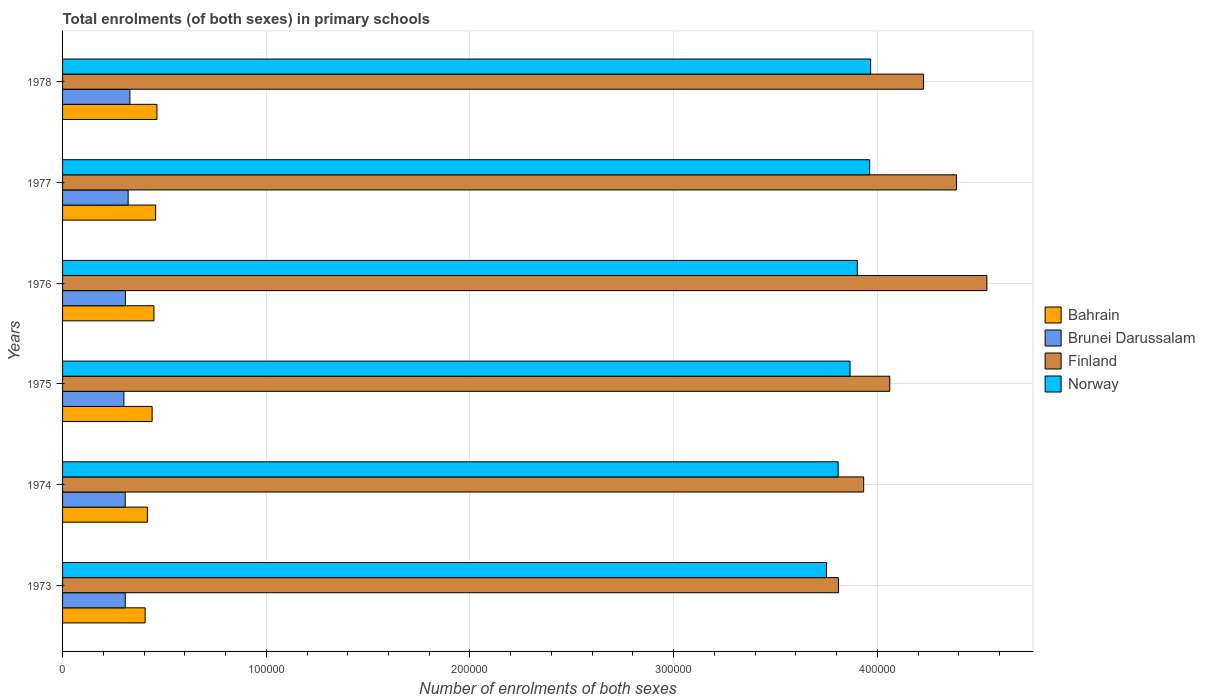How many groups of bars are there?
Your answer should be very brief. 6. What is the label of the 3rd group of bars from the top?
Provide a short and direct response. 1976. In how many cases, is the number of bars for a given year not equal to the number of legend labels?
Your response must be concise. 0. What is the number of enrolments in primary schools in Finland in 1978?
Provide a succinct answer. 4.23e+05. Across all years, what is the maximum number of enrolments in primary schools in Brunei Darussalam?
Offer a terse response. 3.31e+04. Across all years, what is the minimum number of enrolments in primary schools in Brunei Darussalam?
Your answer should be compact. 3.01e+04. In which year was the number of enrolments in primary schools in Bahrain maximum?
Keep it short and to the point. 1978. What is the total number of enrolments in primary schools in Bahrain in the graph?
Offer a very short reply. 2.63e+05. What is the difference between the number of enrolments in primary schools in Brunei Darussalam in 1973 and that in 1976?
Provide a succinct answer. -52. What is the difference between the number of enrolments in primary schools in Brunei Darussalam in 1978 and the number of enrolments in primary schools in Bahrain in 1975?
Provide a succinct answer. -1.09e+04. What is the average number of enrolments in primary schools in Norway per year?
Ensure brevity in your answer.  3.88e+05. In the year 1974, what is the difference between the number of enrolments in primary schools in Finland and number of enrolments in primary schools in Bahrain?
Offer a very short reply. 3.52e+05. What is the ratio of the number of enrolments in primary schools in Finland in 1974 to that in 1977?
Your response must be concise. 0.9. Is the difference between the number of enrolments in primary schools in Finland in 1973 and 1975 greater than the difference between the number of enrolments in primary schools in Bahrain in 1973 and 1975?
Provide a succinct answer. No. What is the difference between the highest and the second highest number of enrolments in primary schools in Norway?
Your answer should be very brief. 478. What is the difference between the highest and the lowest number of enrolments in primary schools in Norway?
Keep it short and to the point. 2.17e+04. In how many years, is the number of enrolments in primary schools in Brunei Darussalam greater than the average number of enrolments in primary schools in Brunei Darussalam taken over all years?
Provide a succinct answer. 2. Is it the case that in every year, the sum of the number of enrolments in primary schools in Norway and number of enrolments in primary schools in Bahrain is greater than the sum of number of enrolments in primary schools in Brunei Darussalam and number of enrolments in primary schools in Finland?
Make the answer very short. Yes. What does the 3rd bar from the top in 1975 represents?
Your answer should be compact. Brunei Darussalam. What does the 1st bar from the bottom in 1975 represents?
Give a very brief answer. Bahrain. Is it the case that in every year, the sum of the number of enrolments in primary schools in Bahrain and number of enrolments in primary schools in Brunei Darussalam is greater than the number of enrolments in primary schools in Norway?
Make the answer very short. No. How many years are there in the graph?
Offer a very short reply. 6. What is the difference between two consecutive major ticks on the X-axis?
Your response must be concise. 1.00e+05. Does the graph contain any zero values?
Your response must be concise. No. Where does the legend appear in the graph?
Keep it short and to the point. Center right. How are the legend labels stacked?
Give a very brief answer. Vertical. What is the title of the graph?
Offer a very short reply. Total enrolments (of both sexes) in primary schools. What is the label or title of the X-axis?
Offer a very short reply. Number of enrolments of both sexes. What is the label or title of the Y-axis?
Offer a very short reply. Years. What is the Number of enrolments of both sexes of Bahrain in 1973?
Your answer should be very brief. 4.05e+04. What is the Number of enrolments of both sexes of Brunei Darussalam in 1973?
Your response must be concise. 3.08e+04. What is the Number of enrolments of both sexes in Finland in 1973?
Your response must be concise. 3.81e+05. What is the Number of enrolments of both sexes of Norway in 1973?
Your response must be concise. 3.75e+05. What is the Number of enrolments of both sexes in Bahrain in 1974?
Offer a terse response. 4.16e+04. What is the Number of enrolments of both sexes in Brunei Darussalam in 1974?
Your answer should be compact. 3.07e+04. What is the Number of enrolments of both sexes in Finland in 1974?
Your response must be concise. 3.93e+05. What is the Number of enrolments of both sexes in Norway in 1974?
Ensure brevity in your answer.  3.81e+05. What is the Number of enrolments of both sexes in Bahrain in 1975?
Make the answer very short. 4.40e+04. What is the Number of enrolments of both sexes of Brunei Darussalam in 1975?
Provide a succinct answer. 3.01e+04. What is the Number of enrolments of both sexes in Finland in 1975?
Offer a very short reply. 4.06e+05. What is the Number of enrolments of both sexes in Norway in 1975?
Give a very brief answer. 3.87e+05. What is the Number of enrolments of both sexes in Bahrain in 1976?
Your answer should be compact. 4.49e+04. What is the Number of enrolments of both sexes of Brunei Darussalam in 1976?
Provide a succinct answer. 3.08e+04. What is the Number of enrolments of both sexes of Finland in 1976?
Give a very brief answer. 4.54e+05. What is the Number of enrolments of both sexes in Norway in 1976?
Provide a succinct answer. 3.90e+05. What is the Number of enrolments of both sexes in Bahrain in 1977?
Offer a terse response. 4.57e+04. What is the Number of enrolments of both sexes of Brunei Darussalam in 1977?
Provide a succinct answer. 3.22e+04. What is the Number of enrolments of both sexes in Finland in 1977?
Keep it short and to the point. 4.39e+05. What is the Number of enrolments of both sexes of Norway in 1977?
Your answer should be very brief. 3.96e+05. What is the Number of enrolments of both sexes of Bahrain in 1978?
Provide a short and direct response. 4.63e+04. What is the Number of enrolments of both sexes in Brunei Darussalam in 1978?
Ensure brevity in your answer.  3.31e+04. What is the Number of enrolments of both sexes of Finland in 1978?
Make the answer very short. 4.23e+05. What is the Number of enrolments of both sexes of Norway in 1978?
Provide a succinct answer. 3.97e+05. Across all years, what is the maximum Number of enrolments of both sexes of Bahrain?
Your response must be concise. 4.63e+04. Across all years, what is the maximum Number of enrolments of both sexes of Brunei Darussalam?
Your response must be concise. 3.31e+04. Across all years, what is the maximum Number of enrolments of both sexes of Finland?
Your answer should be very brief. 4.54e+05. Across all years, what is the maximum Number of enrolments of both sexes of Norway?
Give a very brief answer. 3.97e+05. Across all years, what is the minimum Number of enrolments of both sexes of Bahrain?
Make the answer very short. 4.05e+04. Across all years, what is the minimum Number of enrolments of both sexes in Brunei Darussalam?
Provide a succinct answer. 3.01e+04. Across all years, what is the minimum Number of enrolments of both sexes of Finland?
Keep it short and to the point. 3.81e+05. Across all years, what is the minimum Number of enrolments of both sexes of Norway?
Offer a very short reply. 3.75e+05. What is the total Number of enrolments of both sexes in Bahrain in the graph?
Make the answer very short. 2.63e+05. What is the total Number of enrolments of both sexes in Brunei Darussalam in the graph?
Provide a succinct answer. 1.88e+05. What is the total Number of enrolments of both sexes of Finland in the graph?
Make the answer very short. 2.50e+06. What is the total Number of enrolments of both sexes of Norway in the graph?
Offer a very short reply. 2.33e+06. What is the difference between the Number of enrolments of both sexes of Bahrain in 1973 and that in 1974?
Make the answer very short. -1101. What is the difference between the Number of enrolments of both sexes of Brunei Darussalam in 1973 and that in 1974?
Your answer should be compact. 25. What is the difference between the Number of enrolments of both sexes in Finland in 1973 and that in 1974?
Offer a terse response. -1.24e+04. What is the difference between the Number of enrolments of both sexes in Norway in 1973 and that in 1974?
Offer a very short reply. -5724. What is the difference between the Number of enrolments of both sexes of Bahrain in 1973 and that in 1975?
Your response must be concise. -3435. What is the difference between the Number of enrolments of both sexes of Brunei Darussalam in 1973 and that in 1975?
Keep it short and to the point. 663. What is the difference between the Number of enrolments of both sexes of Finland in 1973 and that in 1975?
Your response must be concise. -2.52e+04. What is the difference between the Number of enrolments of both sexes of Norway in 1973 and that in 1975?
Give a very brief answer. -1.16e+04. What is the difference between the Number of enrolments of both sexes of Bahrain in 1973 and that in 1976?
Offer a terse response. -4327. What is the difference between the Number of enrolments of both sexes of Brunei Darussalam in 1973 and that in 1976?
Ensure brevity in your answer.  -52. What is the difference between the Number of enrolments of both sexes in Finland in 1973 and that in 1976?
Offer a very short reply. -7.29e+04. What is the difference between the Number of enrolments of both sexes in Norway in 1973 and that in 1976?
Make the answer very short. -1.51e+04. What is the difference between the Number of enrolments of both sexes of Bahrain in 1973 and that in 1977?
Give a very brief answer. -5164. What is the difference between the Number of enrolments of both sexes of Brunei Darussalam in 1973 and that in 1977?
Provide a succinct answer. -1416. What is the difference between the Number of enrolments of both sexes in Finland in 1973 and that in 1977?
Ensure brevity in your answer.  -5.79e+04. What is the difference between the Number of enrolments of both sexes in Norway in 1973 and that in 1977?
Your answer should be very brief. -2.12e+04. What is the difference between the Number of enrolments of both sexes in Bahrain in 1973 and that in 1978?
Your response must be concise. -5796. What is the difference between the Number of enrolments of both sexes in Brunei Darussalam in 1973 and that in 1978?
Ensure brevity in your answer.  -2281. What is the difference between the Number of enrolments of both sexes of Finland in 1973 and that in 1978?
Provide a succinct answer. -4.18e+04. What is the difference between the Number of enrolments of both sexes of Norway in 1973 and that in 1978?
Your response must be concise. -2.17e+04. What is the difference between the Number of enrolments of both sexes of Bahrain in 1974 and that in 1975?
Offer a terse response. -2334. What is the difference between the Number of enrolments of both sexes in Brunei Darussalam in 1974 and that in 1975?
Provide a short and direct response. 638. What is the difference between the Number of enrolments of both sexes of Finland in 1974 and that in 1975?
Your answer should be compact. -1.28e+04. What is the difference between the Number of enrolments of both sexes of Norway in 1974 and that in 1975?
Offer a very short reply. -5831. What is the difference between the Number of enrolments of both sexes in Bahrain in 1974 and that in 1976?
Your answer should be very brief. -3226. What is the difference between the Number of enrolments of both sexes in Brunei Darussalam in 1974 and that in 1976?
Your answer should be compact. -77. What is the difference between the Number of enrolments of both sexes of Finland in 1974 and that in 1976?
Offer a very short reply. -6.05e+04. What is the difference between the Number of enrolments of both sexes of Norway in 1974 and that in 1976?
Keep it short and to the point. -9401. What is the difference between the Number of enrolments of both sexes of Bahrain in 1974 and that in 1977?
Your answer should be compact. -4063. What is the difference between the Number of enrolments of both sexes of Brunei Darussalam in 1974 and that in 1977?
Your answer should be very brief. -1441. What is the difference between the Number of enrolments of both sexes in Finland in 1974 and that in 1977?
Your answer should be compact. -4.56e+04. What is the difference between the Number of enrolments of both sexes in Norway in 1974 and that in 1977?
Ensure brevity in your answer.  -1.55e+04. What is the difference between the Number of enrolments of both sexes of Bahrain in 1974 and that in 1978?
Make the answer very short. -4695. What is the difference between the Number of enrolments of both sexes in Brunei Darussalam in 1974 and that in 1978?
Give a very brief answer. -2306. What is the difference between the Number of enrolments of both sexes of Finland in 1974 and that in 1978?
Your answer should be compact. -2.94e+04. What is the difference between the Number of enrolments of both sexes in Norway in 1974 and that in 1978?
Your answer should be compact. -1.59e+04. What is the difference between the Number of enrolments of both sexes of Bahrain in 1975 and that in 1976?
Give a very brief answer. -892. What is the difference between the Number of enrolments of both sexes in Brunei Darussalam in 1975 and that in 1976?
Keep it short and to the point. -715. What is the difference between the Number of enrolments of both sexes of Finland in 1975 and that in 1976?
Offer a terse response. -4.77e+04. What is the difference between the Number of enrolments of both sexes in Norway in 1975 and that in 1976?
Give a very brief answer. -3570. What is the difference between the Number of enrolments of both sexes in Bahrain in 1975 and that in 1977?
Keep it short and to the point. -1729. What is the difference between the Number of enrolments of both sexes in Brunei Darussalam in 1975 and that in 1977?
Provide a short and direct response. -2079. What is the difference between the Number of enrolments of both sexes of Finland in 1975 and that in 1977?
Give a very brief answer. -3.27e+04. What is the difference between the Number of enrolments of both sexes in Norway in 1975 and that in 1977?
Make the answer very short. -9635. What is the difference between the Number of enrolments of both sexes of Bahrain in 1975 and that in 1978?
Your response must be concise. -2361. What is the difference between the Number of enrolments of both sexes in Brunei Darussalam in 1975 and that in 1978?
Give a very brief answer. -2944. What is the difference between the Number of enrolments of both sexes in Finland in 1975 and that in 1978?
Your answer should be compact. -1.66e+04. What is the difference between the Number of enrolments of both sexes of Norway in 1975 and that in 1978?
Your answer should be very brief. -1.01e+04. What is the difference between the Number of enrolments of both sexes in Bahrain in 1976 and that in 1977?
Offer a terse response. -837. What is the difference between the Number of enrolments of both sexes of Brunei Darussalam in 1976 and that in 1977?
Make the answer very short. -1364. What is the difference between the Number of enrolments of both sexes of Finland in 1976 and that in 1977?
Make the answer very short. 1.49e+04. What is the difference between the Number of enrolments of both sexes in Norway in 1976 and that in 1977?
Give a very brief answer. -6065. What is the difference between the Number of enrolments of both sexes of Bahrain in 1976 and that in 1978?
Keep it short and to the point. -1469. What is the difference between the Number of enrolments of both sexes of Brunei Darussalam in 1976 and that in 1978?
Your answer should be compact. -2229. What is the difference between the Number of enrolments of both sexes in Finland in 1976 and that in 1978?
Provide a short and direct response. 3.11e+04. What is the difference between the Number of enrolments of both sexes in Norway in 1976 and that in 1978?
Provide a succinct answer. -6543. What is the difference between the Number of enrolments of both sexes of Bahrain in 1977 and that in 1978?
Offer a very short reply. -632. What is the difference between the Number of enrolments of both sexes in Brunei Darussalam in 1977 and that in 1978?
Provide a succinct answer. -865. What is the difference between the Number of enrolments of both sexes of Finland in 1977 and that in 1978?
Keep it short and to the point. 1.62e+04. What is the difference between the Number of enrolments of both sexes in Norway in 1977 and that in 1978?
Your answer should be compact. -478. What is the difference between the Number of enrolments of both sexes in Bahrain in 1973 and the Number of enrolments of both sexes in Brunei Darussalam in 1974?
Provide a short and direct response. 9783. What is the difference between the Number of enrolments of both sexes of Bahrain in 1973 and the Number of enrolments of both sexes of Finland in 1974?
Give a very brief answer. -3.53e+05. What is the difference between the Number of enrolments of both sexes in Bahrain in 1973 and the Number of enrolments of both sexes in Norway in 1974?
Offer a terse response. -3.40e+05. What is the difference between the Number of enrolments of both sexes in Brunei Darussalam in 1973 and the Number of enrolments of both sexes in Finland in 1974?
Keep it short and to the point. -3.62e+05. What is the difference between the Number of enrolments of both sexes of Brunei Darussalam in 1973 and the Number of enrolments of both sexes of Norway in 1974?
Your answer should be very brief. -3.50e+05. What is the difference between the Number of enrolments of both sexes of Finland in 1973 and the Number of enrolments of both sexes of Norway in 1974?
Your answer should be very brief. 137. What is the difference between the Number of enrolments of both sexes in Bahrain in 1973 and the Number of enrolments of both sexes in Brunei Darussalam in 1975?
Give a very brief answer. 1.04e+04. What is the difference between the Number of enrolments of both sexes of Bahrain in 1973 and the Number of enrolments of both sexes of Finland in 1975?
Your response must be concise. -3.66e+05. What is the difference between the Number of enrolments of both sexes of Bahrain in 1973 and the Number of enrolments of both sexes of Norway in 1975?
Your response must be concise. -3.46e+05. What is the difference between the Number of enrolments of both sexes of Brunei Darussalam in 1973 and the Number of enrolments of both sexes of Finland in 1975?
Keep it short and to the point. -3.75e+05. What is the difference between the Number of enrolments of both sexes of Brunei Darussalam in 1973 and the Number of enrolments of both sexes of Norway in 1975?
Offer a very short reply. -3.56e+05. What is the difference between the Number of enrolments of both sexes of Finland in 1973 and the Number of enrolments of both sexes of Norway in 1975?
Provide a succinct answer. -5694. What is the difference between the Number of enrolments of both sexes of Bahrain in 1973 and the Number of enrolments of both sexes of Brunei Darussalam in 1976?
Provide a short and direct response. 9706. What is the difference between the Number of enrolments of both sexes in Bahrain in 1973 and the Number of enrolments of both sexes in Finland in 1976?
Provide a short and direct response. -4.13e+05. What is the difference between the Number of enrolments of both sexes of Bahrain in 1973 and the Number of enrolments of both sexes of Norway in 1976?
Provide a short and direct response. -3.50e+05. What is the difference between the Number of enrolments of both sexes in Brunei Darussalam in 1973 and the Number of enrolments of both sexes in Finland in 1976?
Offer a terse response. -4.23e+05. What is the difference between the Number of enrolments of both sexes of Brunei Darussalam in 1973 and the Number of enrolments of both sexes of Norway in 1976?
Your answer should be compact. -3.59e+05. What is the difference between the Number of enrolments of both sexes of Finland in 1973 and the Number of enrolments of both sexes of Norway in 1976?
Offer a terse response. -9264. What is the difference between the Number of enrolments of both sexes of Bahrain in 1973 and the Number of enrolments of both sexes of Brunei Darussalam in 1977?
Give a very brief answer. 8342. What is the difference between the Number of enrolments of both sexes in Bahrain in 1973 and the Number of enrolments of both sexes in Finland in 1977?
Provide a succinct answer. -3.98e+05. What is the difference between the Number of enrolments of both sexes of Bahrain in 1973 and the Number of enrolments of both sexes of Norway in 1977?
Your response must be concise. -3.56e+05. What is the difference between the Number of enrolments of both sexes in Brunei Darussalam in 1973 and the Number of enrolments of both sexes in Finland in 1977?
Provide a succinct answer. -4.08e+05. What is the difference between the Number of enrolments of both sexes in Brunei Darussalam in 1973 and the Number of enrolments of both sexes in Norway in 1977?
Give a very brief answer. -3.65e+05. What is the difference between the Number of enrolments of both sexes in Finland in 1973 and the Number of enrolments of both sexes in Norway in 1977?
Make the answer very short. -1.53e+04. What is the difference between the Number of enrolments of both sexes in Bahrain in 1973 and the Number of enrolments of both sexes in Brunei Darussalam in 1978?
Keep it short and to the point. 7477. What is the difference between the Number of enrolments of both sexes in Bahrain in 1973 and the Number of enrolments of both sexes in Finland in 1978?
Provide a short and direct response. -3.82e+05. What is the difference between the Number of enrolments of both sexes of Bahrain in 1973 and the Number of enrolments of both sexes of Norway in 1978?
Provide a short and direct response. -3.56e+05. What is the difference between the Number of enrolments of both sexes in Brunei Darussalam in 1973 and the Number of enrolments of both sexes in Finland in 1978?
Offer a very short reply. -3.92e+05. What is the difference between the Number of enrolments of both sexes of Brunei Darussalam in 1973 and the Number of enrolments of both sexes of Norway in 1978?
Ensure brevity in your answer.  -3.66e+05. What is the difference between the Number of enrolments of both sexes in Finland in 1973 and the Number of enrolments of both sexes in Norway in 1978?
Offer a very short reply. -1.58e+04. What is the difference between the Number of enrolments of both sexes in Bahrain in 1974 and the Number of enrolments of both sexes in Brunei Darussalam in 1975?
Offer a very short reply. 1.15e+04. What is the difference between the Number of enrolments of both sexes in Bahrain in 1974 and the Number of enrolments of both sexes in Finland in 1975?
Keep it short and to the point. -3.64e+05. What is the difference between the Number of enrolments of both sexes of Bahrain in 1974 and the Number of enrolments of both sexes of Norway in 1975?
Ensure brevity in your answer.  -3.45e+05. What is the difference between the Number of enrolments of both sexes in Brunei Darussalam in 1974 and the Number of enrolments of both sexes in Finland in 1975?
Your response must be concise. -3.75e+05. What is the difference between the Number of enrolments of both sexes in Brunei Darussalam in 1974 and the Number of enrolments of both sexes in Norway in 1975?
Provide a succinct answer. -3.56e+05. What is the difference between the Number of enrolments of both sexes of Finland in 1974 and the Number of enrolments of both sexes of Norway in 1975?
Your response must be concise. 6683. What is the difference between the Number of enrolments of both sexes in Bahrain in 1974 and the Number of enrolments of both sexes in Brunei Darussalam in 1976?
Keep it short and to the point. 1.08e+04. What is the difference between the Number of enrolments of both sexes of Bahrain in 1974 and the Number of enrolments of both sexes of Finland in 1976?
Make the answer very short. -4.12e+05. What is the difference between the Number of enrolments of both sexes in Bahrain in 1974 and the Number of enrolments of both sexes in Norway in 1976?
Give a very brief answer. -3.48e+05. What is the difference between the Number of enrolments of both sexes of Brunei Darussalam in 1974 and the Number of enrolments of both sexes of Finland in 1976?
Your response must be concise. -4.23e+05. What is the difference between the Number of enrolments of both sexes in Brunei Darussalam in 1974 and the Number of enrolments of both sexes in Norway in 1976?
Keep it short and to the point. -3.59e+05. What is the difference between the Number of enrolments of both sexes of Finland in 1974 and the Number of enrolments of both sexes of Norway in 1976?
Make the answer very short. 3113. What is the difference between the Number of enrolments of both sexes of Bahrain in 1974 and the Number of enrolments of both sexes of Brunei Darussalam in 1977?
Your response must be concise. 9443. What is the difference between the Number of enrolments of both sexes of Bahrain in 1974 and the Number of enrolments of both sexes of Finland in 1977?
Give a very brief answer. -3.97e+05. What is the difference between the Number of enrolments of both sexes in Bahrain in 1974 and the Number of enrolments of both sexes in Norway in 1977?
Give a very brief answer. -3.55e+05. What is the difference between the Number of enrolments of both sexes of Brunei Darussalam in 1974 and the Number of enrolments of both sexes of Finland in 1977?
Keep it short and to the point. -4.08e+05. What is the difference between the Number of enrolments of both sexes of Brunei Darussalam in 1974 and the Number of enrolments of both sexes of Norway in 1977?
Make the answer very short. -3.65e+05. What is the difference between the Number of enrolments of both sexes of Finland in 1974 and the Number of enrolments of both sexes of Norway in 1977?
Make the answer very short. -2952. What is the difference between the Number of enrolments of both sexes of Bahrain in 1974 and the Number of enrolments of both sexes of Brunei Darussalam in 1978?
Make the answer very short. 8578. What is the difference between the Number of enrolments of both sexes of Bahrain in 1974 and the Number of enrolments of both sexes of Finland in 1978?
Provide a short and direct response. -3.81e+05. What is the difference between the Number of enrolments of both sexes of Bahrain in 1974 and the Number of enrolments of both sexes of Norway in 1978?
Give a very brief answer. -3.55e+05. What is the difference between the Number of enrolments of both sexes in Brunei Darussalam in 1974 and the Number of enrolments of both sexes in Finland in 1978?
Give a very brief answer. -3.92e+05. What is the difference between the Number of enrolments of both sexes of Brunei Darussalam in 1974 and the Number of enrolments of both sexes of Norway in 1978?
Provide a succinct answer. -3.66e+05. What is the difference between the Number of enrolments of both sexes in Finland in 1974 and the Number of enrolments of both sexes in Norway in 1978?
Give a very brief answer. -3430. What is the difference between the Number of enrolments of both sexes of Bahrain in 1975 and the Number of enrolments of both sexes of Brunei Darussalam in 1976?
Provide a short and direct response. 1.31e+04. What is the difference between the Number of enrolments of both sexes of Bahrain in 1975 and the Number of enrolments of both sexes of Finland in 1976?
Your answer should be very brief. -4.10e+05. What is the difference between the Number of enrolments of both sexes of Bahrain in 1975 and the Number of enrolments of both sexes of Norway in 1976?
Your response must be concise. -3.46e+05. What is the difference between the Number of enrolments of both sexes in Brunei Darussalam in 1975 and the Number of enrolments of both sexes in Finland in 1976?
Your response must be concise. -4.24e+05. What is the difference between the Number of enrolments of both sexes of Brunei Darussalam in 1975 and the Number of enrolments of both sexes of Norway in 1976?
Keep it short and to the point. -3.60e+05. What is the difference between the Number of enrolments of both sexes in Finland in 1975 and the Number of enrolments of both sexes in Norway in 1976?
Offer a terse response. 1.59e+04. What is the difference between the Number of enrolments of both sexes in Bahrain in 1975 and the Number of enrolments of both sexes in Brunei Darussalam in 1977?
Give a very brief answer. 1.18e+04. What is the difference between the Number of enrolments of both sexes in Bahrain in 1975 and the Number of enrolments of both sexes in Finland in 1977?
Your answer should be very brief. -3.95e+05. What is the difference between the Number of enrolments of both sexes in Bahrain in 1975 and the Number of enrolments of both sexes in Norway in 1977?
Keep it short and to the point. -3.52e+05. What is the difference between the Number of enrolments of both sexes of Brunei Darussalam in 1975 and the Number of enrolments of both sexes of Finland in 1977?
Ensure brevity in your answer.  -4.09e+05. What is the difference between the Number of enrolments of both sexes of Brunei Darussalam in 1975 and the Number of enrolments of both sexes of Norway in 1977?
Give a very brief answer. -3.66e+05. What is the difference between the Number of enrolments of both sexes in Finland in 1975 and the Number of enrolments of both sexes in Norway in 1977?
Provide a short and direct response. 9864. What is the difference between the Number of enrolments of both sexes of Bahrain in 1975 and the Number of enrolments of both sexes of Brunei Darussalam in 1978?
Ensure brevity in your answer.  1.09e+04. What is the difference between the Number of enrolments of both sexes of Bahrain in 1975 and the Number of enrolments of both sexes of Finland in 1978?
Your response must be concise. -3.79e+05. What is the difference between the Number of enrolments of both sexes of Bahrain in 1975 and the Number of enrolments of both sexes of Norway in 1978?
Make the answer very short. -3.53e+05. What is the difference between the Number of enrolments of both sexes of Brunei Darussalam in 1975 and the Number of enrolments of both sexes of Finland in 1978?
Offer a terse response. -3.93e+05. What is the difference between the Number of enrolments of both sexes of Brunei Darussalam in 1975 and the Number of enrolments of both sexes of Norway in 1978?
Ensure brevity in your answer.  -3.67e+05. What is the difference between the Number of enrolments of both sexes of Finland in 1975 and the Number of enrolments of both sexes of Norway in 1978?
Your answer should be compact. 9386. What is the difference between the Number of enrolments of both sexes of Bahrain in 1976 and the Number of enrolments of both sexes of Brunei Darussalam in 1977?
Give a very brief answer. 1.27e+04. What is the difference between the Number of enrolments of both sexes of Bahrain in 1976 and the Number of enrolments of both sexes of Finland in 1977?
Your response must be concise. -3.94e+05. What is the difference between the Number of enrolments of both sexes in Bahrain in 1976 and the Number of enrolments of both sexes in Norway in 1977?
Your answer should be very brief. -3.51e+05. What is the difference between the Number of enrolments of both sexes of Brunei Darussalam in 1976 and the Number of enrolments of both sexes of Finland in 1977?
Keep it short and to the point. -4.08e+05. What is the difference between the Number of enrolments of both sexes in Brunei Darussalam in 1976 and the Number of enrolments of both sexes in Norway in 1977?
Your response must be concise. -3.65e+05. What is the difference between the Number of enrolments of both sexes of Finland in 1976 and the Number of enrolments of both sexes of Norway in 1977?
Keep it short and to the point. 5.75e+04. What is the difference between the Number of enrolments of both sexes in Bahrain in 1976 and the Number of enrolments of both sexes in Brunei Darussalam in 1978?
Your answer should be very brief. 1.18e+04. What is the difference between the Number of enrolments of both sexes in Bahrain in 1976 and the Number of enrolments of both sexes in Finland in 1978?
Provide a short and direct response. -3.78e+05. What is the difference between the Number of enrolments of both sexes of Bahrain in 1976 and the Number of enrolments of both sexes of Norway in 1978?
Make the answer very short. -3.52e+05. What is the difference between the Number of enrolments of both sexes of Brunei Darussalam in 1976 and the Number of enrolments of both sexes of Finland in 1978?
Keep it short and to the point. -3.92e+05. What is the difference between the Number of enrolments of both sexes in Brunei Darussalam in 1976 and the Number of enrolments of both sexes in Norway in 1978?
Provide a short and direct response. -3.66e+05. What is the difference between the Number of enrolments of both sexes of Finland in 1976 and the Number of enrolments of both sexes of Norway in 1978?
Offer a very short reply. 5.71e+04. What is the difference between the Number of enrolments of both sexes of Bahrain in 1977 and the Number of enrolments of both sexes of Brunei Darussalam in 1978?
Give a very brief answer. 1.26e+04. What is the difference between the Number of enrolments of both sexes in Bahrain in 1977 and the Number of enrolments of both sexes in Finland in 1978?
Make the answer very short. -3.77e+05. What is the difference between the Number of enrolments of both sexes of Bahrain in 1977 and the Number of enrolments of both sexes of Norway in 1978?
Offer a terse response. -3.51e+05. What is the difference between the Number of enrolments of both sexes of Brunei Darussalam in 1977 and the Number of enrolments of both sexes of Finland in 1978?
Provide a succinct answer. -3.90e+05. What is the difference between the Number of enrolments of both sexes of Brunei Darussalam in 1977 and the Number of enrolments of both sexes of Norway in 1978?
Offer a terse response. -3.64e+05. What is the difference between the Number of enrolments of both sexes in Finland in 1977 and the Number of enrolments of both sexes in Norway in 1978?
Ensure brevity in your answer.  4.21e+04. What is the average Number of enrolments of both sexes in Bahrain per year?
Provide a short and direct response. 4.38e+04. What is the average Number of enrolments of both sexes of Brunei Darussalam per year?
Provide a succinct answer. 3.13e+04. What is the average Number of enrolments of both sexes of Finland per year?
Your answer should be compact. 4.16e+05. What is the average Number of enrolments of both sexes of Norway per year?
Give a very brief answer. 3.88e+05. In the year 1973, what is the difference between the Number of enrolments of both sexes in Bahrain and Number of enrolments of both sexes in Brunei Darussalam?
Keep it short and to the point. 9758. In the year 1973, what is the difference between the Number of enrolments of both sexes in Bahrain and Number of enrolments of both sexes in Finland?
Ensure brevity in your answer.  -3.40e+05. In the year 1973, what is the difference between the Number of enrolments of both sexes in Bahrain and Number of enrolments of both sexes in Norway?
Keep it short and to the point. -3.34e+05. In the year 1973, what is the difference between the Number of enrolments of both sexes of Brunei Darussalam and Number of enrolments of both sexes of Finland?
Ensure brevity in your answer.  -3.50e+05. In the year 1973, what is the difference between the Number of enrolments of both sexes of Brunei Darussalam and Number of enrolments of both sexes of Norway?
Your response must be concise. -3.44e+05. In the year 1973, what is the difference between the Number of enrolments of both sexes in Finland and Number of enrolments of both sexes in Norway?
Provide a short and direct response. 5861. In the year 1974, what is the difference between the Number of enrolments of both sexes in Bahrain and Number of enrolments of both sexes in Brunei Darussalam?
Provide a succinct answer. 1.09e+04. In the year 1974, what is the difference between the Number of enrolments of both sexes of Bahrain and Number of enrolments of both sexes of Finland?
Provide a succinct answer. -3.52e+05. In the year 1974, what is the difference between the Number of enrolments of both sexes of Bahrain and Number of enrolments of both sexes of Norway?
Give a very brief answer. -3.39e+05. In the year 1974, what is the difference between the Number of enrolments of both sexes in Brunei Darussalam and Number of enrolments of both sexes in Finland?
Give a very brief answer. -3.62e+05. In the year 1974, what is the difference between the Number of enrolments of both sexes of Brunei Darussalam and Number of enrolments of both sexes of Norway?
Give a very brief answer. -3.50e+05. In the year 1974, what is the difference between the Number of enrolments of both sexes in Finland and Number of enrolments of both sexes in Norway?
Ensure brevity in your answer.  1.25e+04. In the year 1975, what is the difference between the Number of enrolments of both sexes of Bahrain and Number of enrolments of both sexes of Brunei Darussalam?
Make the answer very short. 1.39e+04. In the year 1975, what is the difference between the Number of enrolments of both sexes of Bahrain and Number of enrolments of both sexes of Finland?
Provide a short and direct response. -3.62e+05. In the year 1975, what is the difference between the Number of enrolments of both sexes in Bahrain and Number of enrolments of both sexes in Norway?
Give a very brief answer. -3.43e+05. In the year 1975, what is the difference between the Number of enrolments of both sexes in Brunei Darussalam and Number of enrolments of both sexes in Finland?
Keep it short and to the point. -3.76e+05. In the year 1975, what is the difference between the Number of enrolments of both sexes in Brunei Darussalam and Number of enrolments of both sexes in Norway?
Your answer should be very brief. -3.56e+05. In the year 1975, what is the difference between the Number of enrolments of both sexes in Finland and Number of enrolments of both sexes in Norway?
Offer a terse response. 1.95e+04. In the year 1976, what is the difference between the Number of enrolments of both sexes in Bahrain and Number of enrolments of both sexes in Brunei Darussalam?
Provide a short and direct response. 1.40e+04. In the year 1976, what is the difference between the Number of enrolments of both sexes in Bahrain and Number of enrolments of both sexes in Finland?
Your answer should be very brief. -4.09e+05. In the year 1976, what is the difference between the Number of enrolments of both sexes in Bahrain and Number of enrolments of both sexes in Norway?
Offer a very short reply. -3.45e+05. In the year 1976, what is the difference between the Number of enrolments of both sexes of Brunei Darussalam and Number of enrolments of both sexes of Finland?
Your answer should be very brief. -4.23e+05. In the year 1976, what is the difference between the Number of enrolments of both sexes in Brunei Darussalam and Number of enrolments of both sexes in Norway?
Make the answer very short. -3.59e+05. In the year 1976, what is the difference between the Number of enrolments of both sexes of Finland and Number of enrolments of both sexes of Norway?
Ensure brevity in your answer.  6.36e+04. In the year 1977, what is the difference between the Number of enrolments of both sexes in Bahrain and Number of enrolments of both sexes in Brunei Darussalam?
Provide a short and direct response. 1.35e+04. In the year 1977, what is the difference between the Number of enrolments of both sexes in Bahrain and Number of enrolments of both sexes in Finland?
Offer a very short reply. -3.93e+05. In the year 1977, what is the difference between the Number of enrolments of both sexes of Bahrain and Number of enrolments of both sexes of Norway?
Offer a terse response. -3.50e+05. In the year 1977, what is the difference between the Number of enrolments of both sexes in Brunei Darussalam and Number of enrolments of both sexes in Finland?
Ensure brevity in your answer.  -4.07e+05. In the year 1977, what is the difference between the Number of enrolments of both sexes of Brunei Darussalam and Number of enrolments of both sexes of Norway?
Your response must be concise. -3.64e+05. In the year 1977, what is the difference between the Number of enrolments of both sexes of Finland and Number of enrolments of both sexes of Norway?
Give a very brief answer. 4.26e+04. In the year 1978, what is the difference between the Number of enrolments of both sexes of Bahrain and Number of enrolments of both sexes of Brunei Darussalam?
Provide a succinct answer. 1.33e+04. In the year 1978, what is the difference between the Number of enrolments of both sexes in Bahrain and Number of enrolments of both sexes in Finland?
Your answer should be compact. -3.76e+05. In the year 1978, what is the difference between the Number of enrolments of both sexes in Bahrain and Number of enrolments of both sexes in Norway?
Your answer should be very brief. -3.50e+05. In the year 1978, what is the difference between the Number of enrolments of both sexes of Brunei Darussalam and Number of enrolments of both sexes of Finland?
Your response must be concise. -3.90e+05. In the year 1978, what is the difference between the Number of enrolments of both sexes in Brunei Darussalam and Number of enrolments of both sexes in Norway?
Provide a short and direct response. -3.64e+05. In the year 1978, what is the difference between the Number of enrolments of both sexes of Finland and Number of enrolments of both sexes of Norway?
Your answer should be very brief. 2.60e+04. What is the ratio of the Number of enrolments of both sexes of Bahrain in 1973 to that in 1974?
Offer a very short reply. 0.97. What is the ratio of the Number of enrolments of both sexes of Finland in 1973 to that in 1974?
Your response must be concise. 0.97. What is the ratio of the Number of enrolments of both sexes in Norway in 1973 to that in 1974?
Provide a succinct answer. 0.98. What is the ratio of the Number of enrolments of both sexes in Bahrain in 1973 to that in 1975?
Your answer should be very brief. 0.92. What is the ratio of the Number of enrolments of both sexes of Brunei Darussalam in 1973 to that in 1975?
Your response must be concise. 1.02. What is the ratio of the Number of enrolments of both sexes in Finland in 1973 to that in 1975?
Offer a terse response. 0.94. What is the ratio of the Number of enrolments of both sexes of Norway in 1973 to that in 1975?
Ensure brevity in your answer.  0.97. What is the ratio of the Number of enrolments of both sexes of Bahrain in 1973 to that in 1976?
Offer a very short reply. 0.9. What is the ratio of the Number of enrolments of both sexes of Finland in 1973 to that in 1976?
Ensure brevity in your answer.  0.84. What is the ratio of the Number of enrolments of both sexes in Norway in 1973 to that in 1976?
Keep it short and to the point. 0.96. What is the ratio of the Number of enrolments of both sexes of Bahrain in 1973 to that in 1977?
Offer a terse response. 0.89. What is the ratio of the Number of enrolments of both sexes of Brunei Darussalam in 1973 to that in 1977?
Your answer should be very brief. 0.96. What is the ratio of the Number of enrolments of both sexes of Finland in 1973 to that in 1977?
Your answer should be very brief. 0.87. What is the ratio of the Number of enrolments of both sexes of Norway in 1973 to that in 1977?
Your response must be concise. 0.95. What is the ratio of the Number of enrolments of both sexes of Bahrain in 1973 to that in 1978?
Your response must be concise. 0.87. What is the ratio of the Number of enrolments of both sexes in Finland in 1973 to that in 1978?
Offer a very short reply. 0.9. What is the ratio of the Number of enrolments of both sexes in Norway in 1973 to that in 1978?
Your response must be concise. 0.95. What is the ratio of the Number of enrolments of both sexes of Bahrain in 1974 to that in 1975?
Give a very brief answer. 0.95. What is the ratio of the Number of enrolments of both sexes of Brunei Darussalam in 1974 to that in 1975?
Ensure brevity in your answer.  1.02. What is the ratio of the Number of enrolments of both sexes of Finland in 1974 to that in 1975?
Provide a succinct answer. 0.97. What is the ratio of the Number of enrolments of both sexes of Norway in 1974 to that in 1975?
Ensure brevity in your answer.  0.98. What is the ratio of the Number of enrolments of both sexes in Bahrain in 1974 to that in 1976?
Provide a short and direct response. 0.93. What is the ratio of the Number of enrolments of both sexes of Finland in 1974 to that in 1976?
Give a very brief answer. 0.87. What is the ratio of the Number of enrolments of both sexes in Norway in 1974 to that in 1976?
Provide a short and direct response. 0.98. What is the ratio of the Number of enrolments of both sexes in Bahrain in 1974 to that in 1977?
Make the answer very short. 0.91. What is the ratio of the Number of enrolments of both sexes in Brunei Darussalam in 1974 to that in 1977?
Provide a short and direct response. 0.96. What is the ratio of the Number of enrolments of both sexes in Finland in 1974 to that in 1977?
Offer a terse response. 0.9. What is the ratio of the Number of enrolments of both sexes in Bahrain in 1974 to that in 1978?
Make the answer very short. 0.9. What is the ratio of the Number of enrolments of both sexes in Brunei Darussalam in 1974 to that in 1978?
Provide a short and direct response. 0.93. What is the ratio of the Number of enrolments of both sexes of Finland in 1974 to that in 1978?
Ensure brevity in your answer.  0.93. What is the ratio of the Number of enrolments of both sexes of Norway in 1974 to that in 1978?
Offer a very short reply. 0.96. What is the ratio of the Number of enrolments of both sexes in Bahrain in 1975 to that in 1976?
Your response must be concise. 0.98. What is the ratio of the Number of enrolments of both sexes in Brunei Darussalam in 1975 to that in 1976?
Your response must be concise. 0.98. What is the ratio of the Number of enrolments of both sexes of Finland in 1975 to that in 1976?
Provide a short and direct response. 0.89. What is the ratio of the Number of enrolments of both sexes in Norway in 1975 to that in 1976?
Keep it short and to the point. 0.99. What is the ratio of the Number of enrolments of both sexes in Bahrain in 1975 to that in 1977?
Your answer should be very brief. 0.96. What is the ratio of the Number of enrolments of both sexes of Brunei Darussalam in 1975 to that in 1977?
Keep it short and to the point. 0.94. What is the ratio of the Number of enrolments of both sexes in Finland in 1975 to that in 1977?
Keep it short and to the point. 0.93. What is the ratio of the Number of enrolments of both sexes of Norway in 1975 to that in 1977?
Your response must be concise. 0.98. What is the ratio of the Number of enrolments of both sexes of Bahrain in 1975 to that in 1978?
Provide a succinct answer. 0.95. What is the ratio of the Number of enrolments of both sexes in Brunei Darussalam in 1975 to that in 1978?
Your response must be concise. 0.91. What is the ratio of the Number of enrolments of both sexes of Finland in 1975 to that in 1978?
Provide a short and direct response. 0.96. What is the ratio of the Number of enrolments of both sexes of Norway in 1975 to that in 1978?
Provide a short and direct response. 0.97. What is the ratio of the Number of enrolments of both sexes of Bahrain in 1976 to that in 1977?
Give a very brief answer. 0.98. What is the ratio of the Number of enrolments of both sexes in Brunei Darussalam in 1976 to that in 1977?
Provide a short and direct response. 0.96. What is the ratio of the Number of enrolments of both sexes of Finland in 1976 to that in 1977?
Provide a short and direct response. 1.03. What is the ratio of the Number of enrolments of both sexes of Norway in 1976 to that in 1977?
Make the answer very short. 0.98. What is the ratio of the Number of enrolments of both sexes of Bahrain in 1976 to that in 1978?
Provide a succinct answer. 0.97. What is the ratio of the Number of enrolments of both sexes in Brunei Darussalam in 1976 to that in 1978?
Your response must be concise. 0.93. What is the ratio of the Number of enrolments of both sexes of Finland in 1976 to that in 1978?
Provide a succinct answer. 1.07. What is the ratio of the Number of enrolments of both sexes of Norway in 1976 to that in 1978?
Your answer should be compact. 0.98. What is the ratio of the Number of enrolments of both sexes of Bahrain in 1977 to that in 1978?
Your answer should be compact. 0.99. What is the ratio of the Number of enrolments of both sexes in Brunei Darussalam in 1977 to that in 1978?
Offer a terse response. 0.97. What is the ratio of the Number of enrolments of both sexes of Finland in 1977 to that in 1978?
Your answer should be compact. 1.04. What is the difference between the highest and the second highest Number of enrolments of both sexes in Bahrain?
Offer a very short reply. 632. What is the difference between the highest and the second highest Number of enrolments of both sexes of Brunei Darussalam?
Make the answer very short. 865. What is the difference between the highest and the second highest Number of enrolments of both sexes of Finland?
Provide a short and direct response. 1.49e+04. What is the difference between the highest and the second highest Number of enrolments of both sexes in Norway?
Provide a short and direct response. 478. What is the difference between the highest and the lowest Number of enrolments of both sexes of Bahrain?
Your response must be concise. 5796. What is the difference between the highest and the lowest Number of enrolments of both sexes in Brunei Darussalam?
Your answer should be very brief. 2944. What is the difference between the highest and the lowest Number of enrolments of both sexes of Finland?
Keep it short and to the point. 7.29e+04. What is the difference between the highest and the lowest Number of enrolments of both sexes of Norway?
Provide a succinct answer. 2.17e+04. 